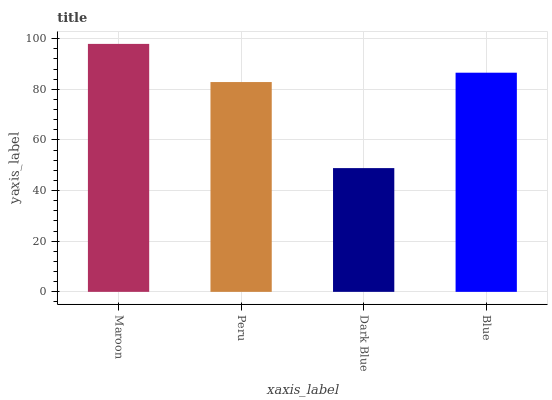Is Dark Blue the minimum?
Answer yes or no. Yes. Is Maroon the maximum?
Answer yes or no. Yes. Is Peru the minimum?
Answer yes or no. No. Is Peru the maximum?
Answer yes or no. No. Is Maroon greater than Peru?
Answer yes or no. Yes. Is Peru less than Maroon?
Answer yes or no. Yes. Is Peru greater than Maroon?
Answer yes or no. No. Is Maroon less than Peru?
Answer yes or no. No. Is Blue the high median?
Answer yes or no. Yes. Is Peru the low median?
Answer yes or no. Yes. Is Dark Blue the high median?
Answer yes or no. No. Is Dark Blue the low median?
Answer yes or no. No. 